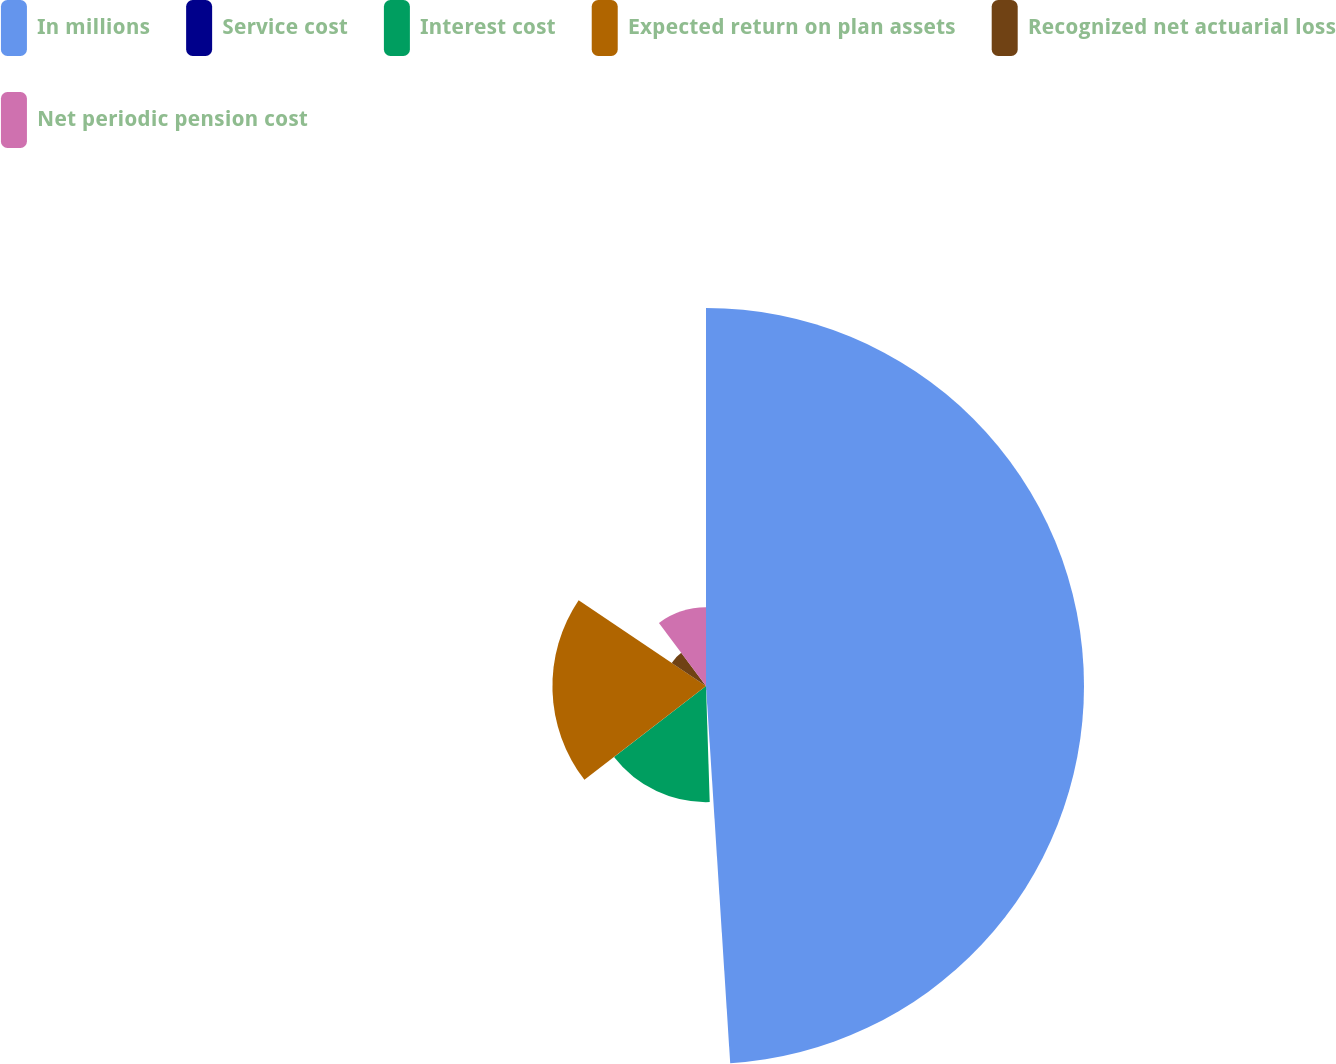<chart> <loc_0><loc_0><loc_500><loc_500><pie_chart><fcel>In millions<fcel>Service cost<fcel>Interest cost<fcel>Expected return on plan assets<fcel>Recognized net actuarial loss<fcel>Net periodic pension cost<nl><fcel>48.98%<fcel>0.51%<fcel>15.05%<fcel>19.9%<fcel>5.36%<fcel>10.2%<nl></chart> 